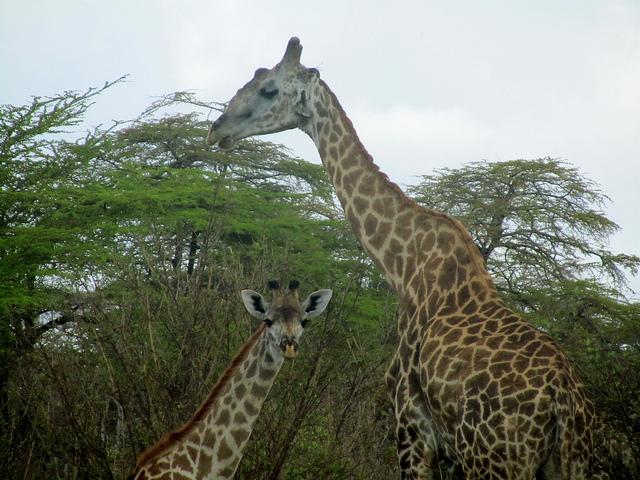Are they both adult giraffes?
Concise answer only. No. Are the giraffes in their natural habitat?
Short answer required. Yes. How many giraffes are there?
Write a very short answer. 2. Are these giraffes outside or inside?
Be succinct. Outside. How many giraffe are in the forest?
Answer briefly. 2. What color is the giraffes head?
Quick response, please. Brown and white. How many giraffes are pictured?
Concise answer only. 2. Are there wires?
Concise answer only. No. Does the giraffe look hungry?
Quick response, please. Yes. How many giraffes can be seen?
Give a very brief answer. 2. What kind of trees are there?
Give a very brief answer. Green. Are both giraffes looking in the same direction?
Answer briefly. No. Are any of the giraffes mouths open?
Short answer required. No. 